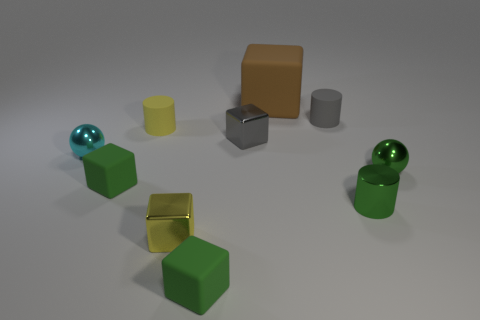How many other things are the same color as the big matte thing?
Your response must be concise. 0. Are there an equal number of green metallic cylinders that are in front of the tiny gray block and yellow blocks?
Your response must be concise. Yes. How many small gray things are on the left side of the tiny matte cylinder that is behind the rubber cylinder that is on the left side of the small gray rubber cylinder?
Provide a short and direct response. 1. Is there any other thing that is the same size as the brown rubber object?
Your answer should be very brief. No. There is a metallic cylinder; is it the same size as the rubber block to the left of the yellow matte thing?
Make the answer very short. Yes. What number of cyan things are there?
Your answer should be compact. 1. Does the sphere that is to the right of the brown object have the same size as the matte block that is behind the cyan metal object?
Keep it short and to the point. No. The other small rubber thing that is the same shape as the tiny gray matte object is what color?
Your answer should be very brief. Yellow. Is the shape of the big brown object the same as the gray metallic object?
Provide a short and direct response. Yes. There is a yellow metal object that is the same shape as the brown thing; what is its size?
Offer a terse response. Small. 